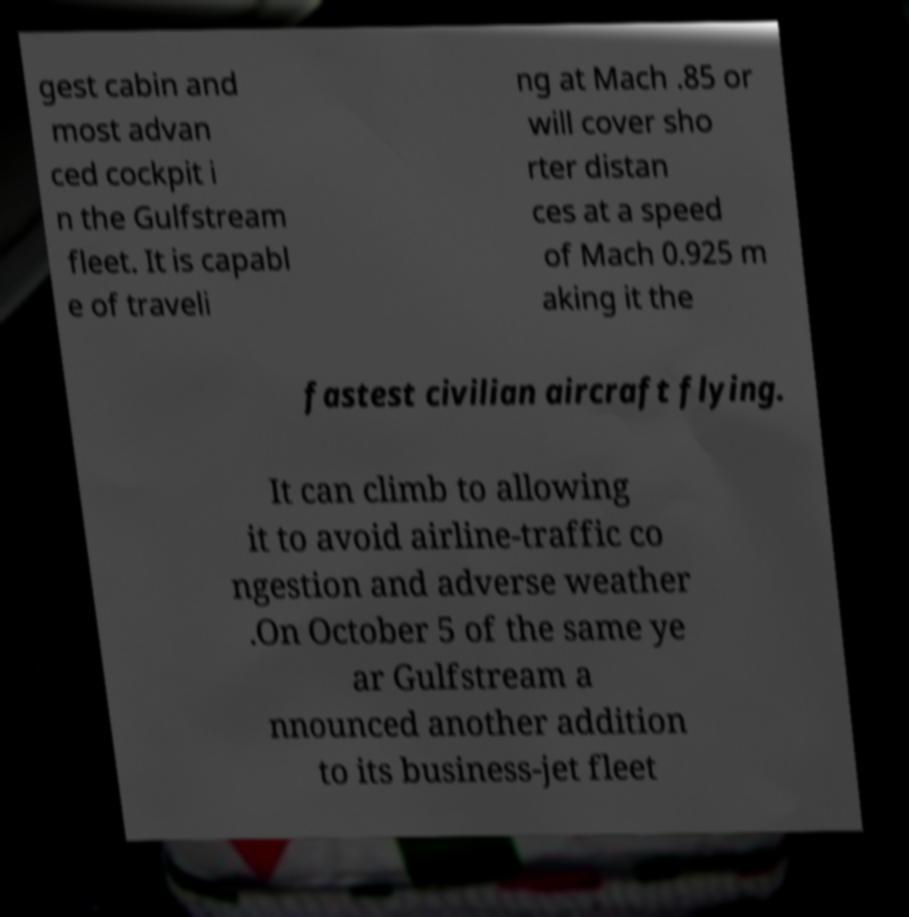Can you accurately transcribe the text from the provided image for me? gest cabin and most advan ced cockpit i n the Gulfstream fleet. It is capabl e of traveli ng at Mach .85 or will cover sho rter distan ces at a speed of Mach 0.925 m aking it the fastest civilian aircraft flying. It can climb to allowing it to avoid airline-traffic co ngestion and adverse weather .On October 5 of the same ye ar Gulfstream a nnounced another addition to its business-jet fleet 